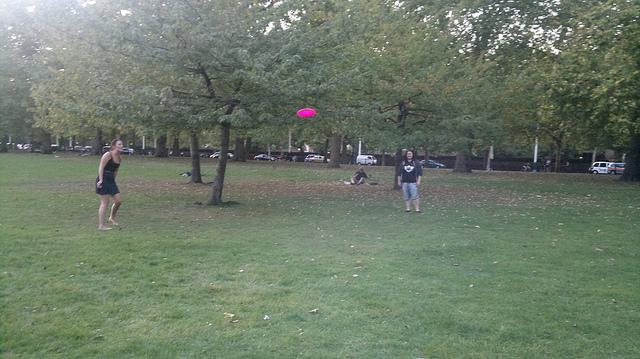What color is the woman's shirt?
Quick response, please. Black. Is this a mountainous area?
Answer briefly. No. What game are these people playing?
Short answer required. Frisbee. What are the people doing?
Keep it brief. Frisbee. Are there cars?
Write a very short answer. Yes. Is there an audience?
Write a very short answer. No. What is the color of the frisbee?
Answer briefly. Pink. Where are these people at?
Answer briefly. Park. What breed of dog is this?
Keep it brief. No dog. 